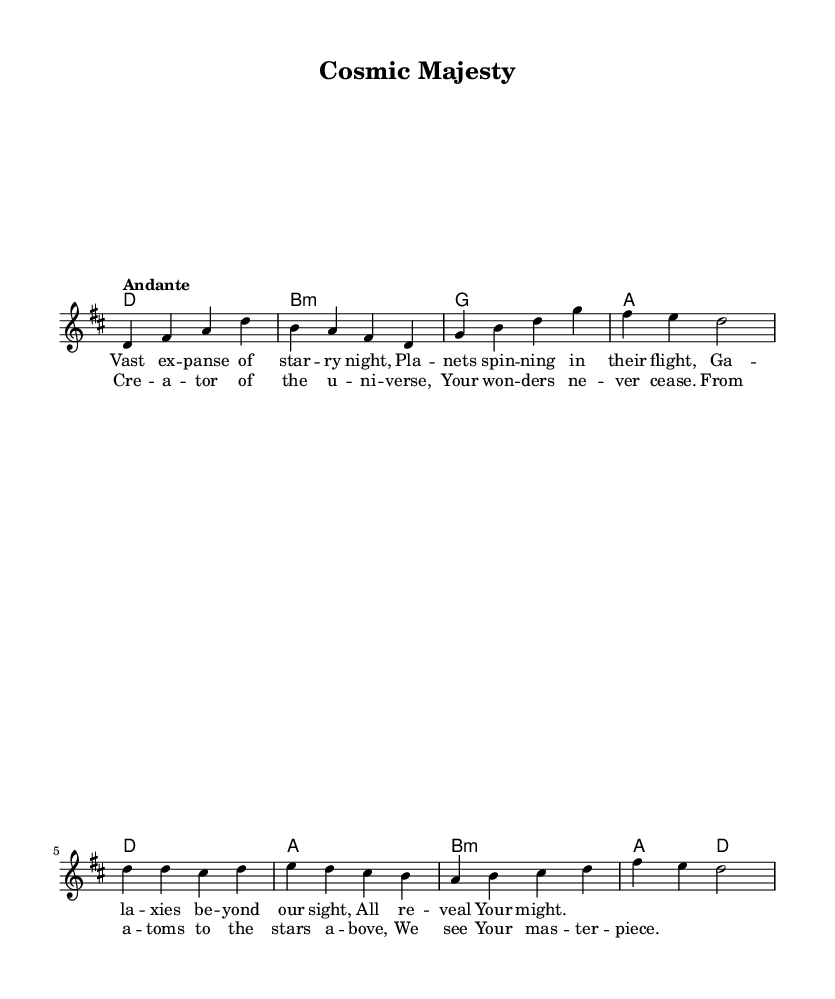What is the key signature of this music? The key signature is D major, which has two sharps: F# and C#.
Answer: D major What is the time signature of this piece? The time signature is 4/4, indicating there are four beats in each measure.
Answer: 4/4 What is the tempo marking for this hymn? The tempo marking is "Andante," suggesting a moderately slow pace.
Answer: Andante How many verses are in this hymn? The hymn contains one verse, as indicated by the lyrics section focused on a single poetic stanza.
Answer: One Which chord appears first in the harmony section? The first chord in the harmony section is D major, indicated in the first measure.
Answer: D What theme do the lyrics of this hymn encompass? The lyrics reflect a theme of God's creation and the vastness of the universe, emphasizing the majesty of creation.
Answer: God's creation and the universe What is the last word of the chorus lyrics? The last word of the chorus is "piece," which is the final word of the statement admiring the wonders of the Creator.
Answer: piece 